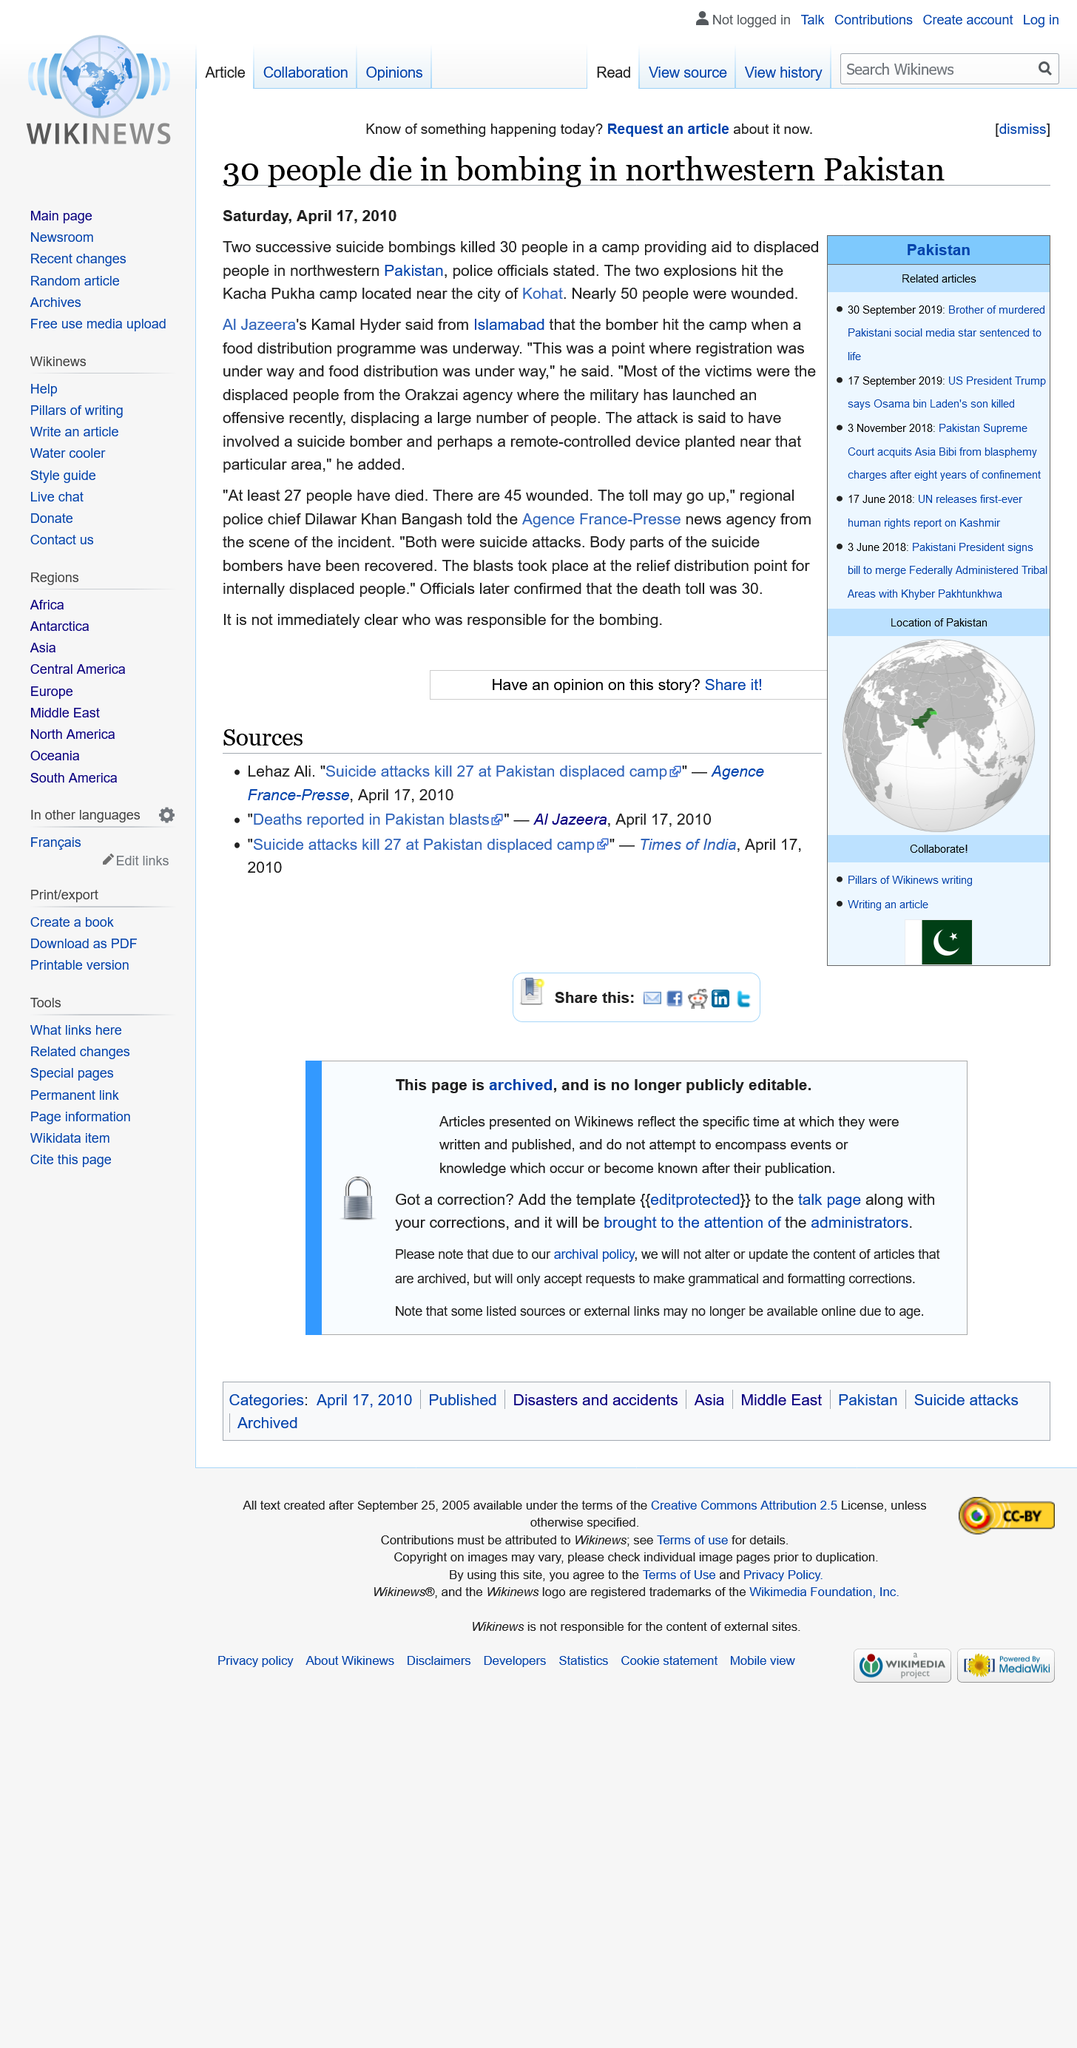Draw attention to some important aspects in this diagram. The Kacha Pukha camp suicide bombings resulted in the loss of numerous lives, with the vast majority of the victims hailing from the Orakzai agency. On April 17, 2010, a suicide bombing attack occurred at Kacha Pukha camp, resulting in the deaths of 30 individuals. Out of the 60 individuals who were injured in the Kacha Pukha camp suicide bombings, only a small number, nearly 50, were fortunate enough to escape without fatality. 